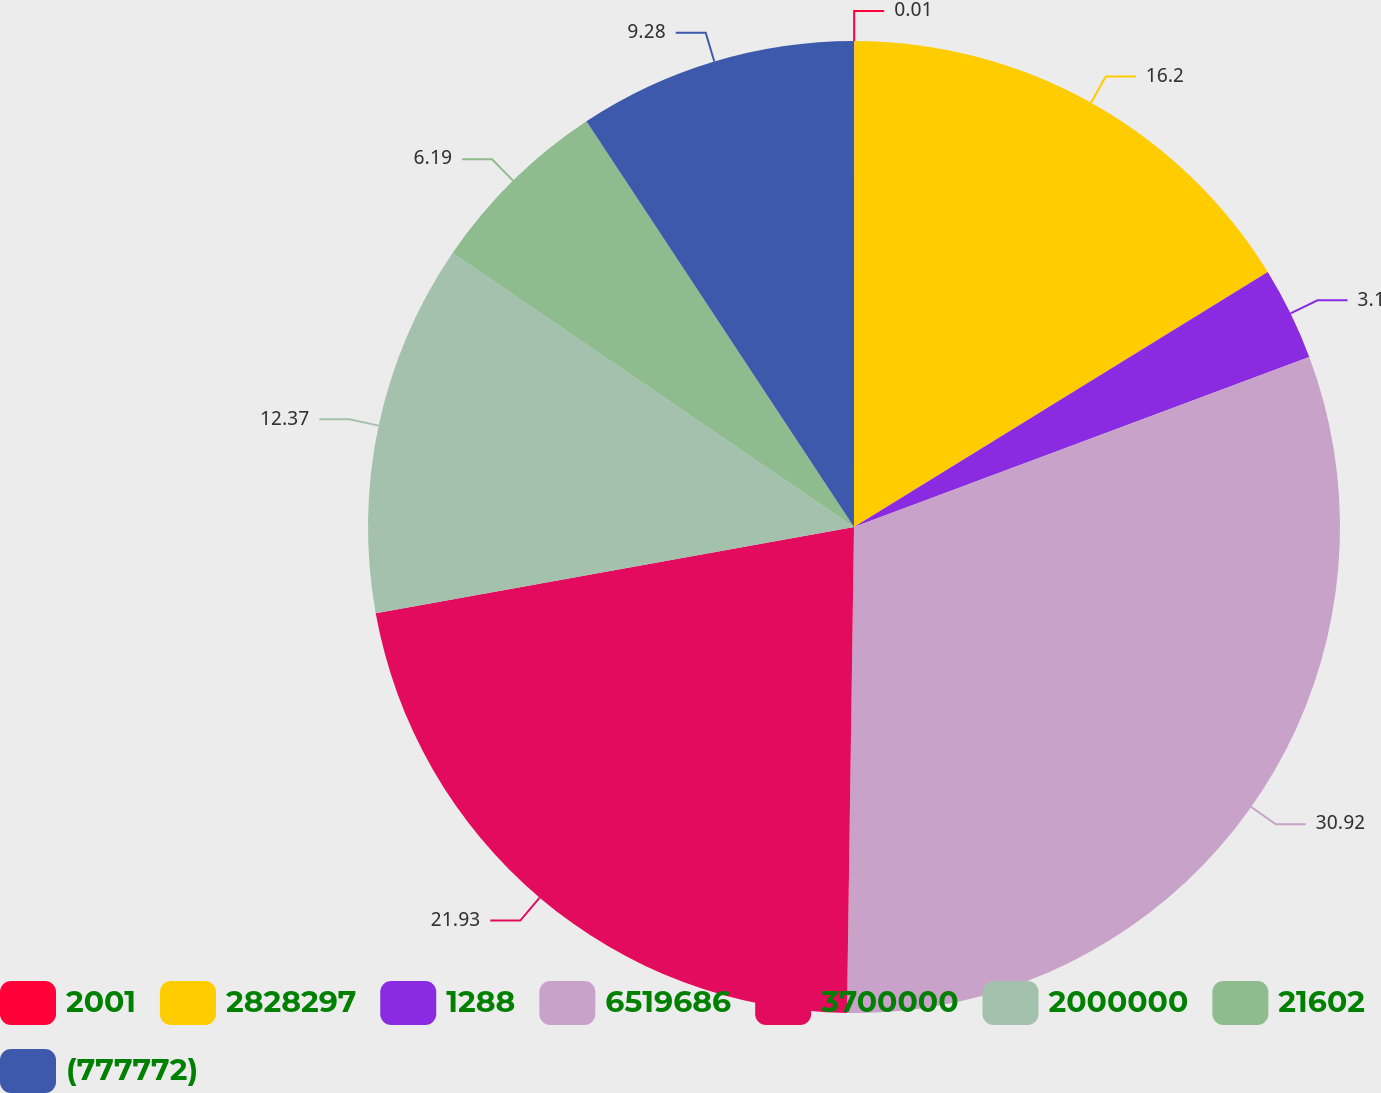<chart> <loc_0><loc_0><loc_500><loc_500><pie_chart><fcel>2001<fcel>2828297<fcel>1288<fcel>6519686<fcel>3700000<fcel>2000000<fcel>21602<fcel>(777772)<nl><fcel>0.01%<fcel>16.2%<fcel>3.1%<fcel>30.92%<fcel>21.93%<fcel>12.37%<fcel>6.19%<fcel>9.28%<nl></chart> 